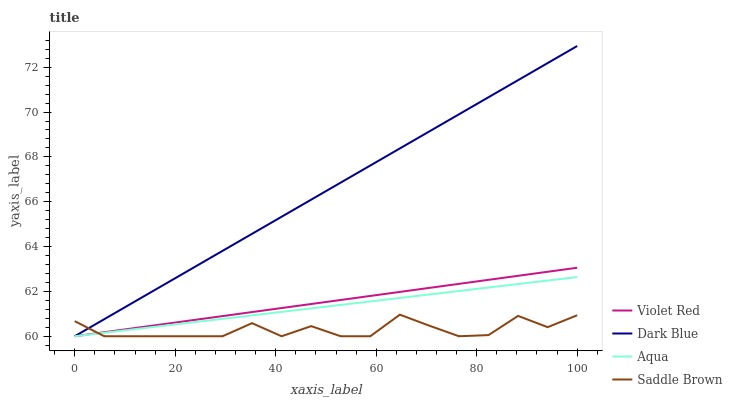Does Saddle Brown have the minimum area under the curve?
Answer yes or no. Yes. Does Dark Blue have the maximum area under the curve?
Answer yes or no. Yes. Does Violet Red have the minimum area under the curve?
Answer yes or no. No. Does Violet Red have the maximum area under the curve?
Answer yes or no. No. Is Dark Blue the smoothest?
Answer yes or no. Yes. Is Saddle Brown the roughest?
Answer yes or no. Yes. Is Violet Red the smoothest?
Answer yes or no. No. Is Violet Red the roughest?
Answer yes or no. No. Does Dark Blue have the lowest value?
Answer yes or no. Yes. Does Dark Blue have the highest value?
Answer yes or no. Yes. Does Violet Red have the highest value?
Answer yes or no. No. Does Dark Blue intersect Saddle Brown?
Answer yes or no. Yes. Is Dark Blue less than Saddle Brown?
Answer yes or no. No. Is Dark Blue greater than Saddle Brown?
Answer yes or no. No. 